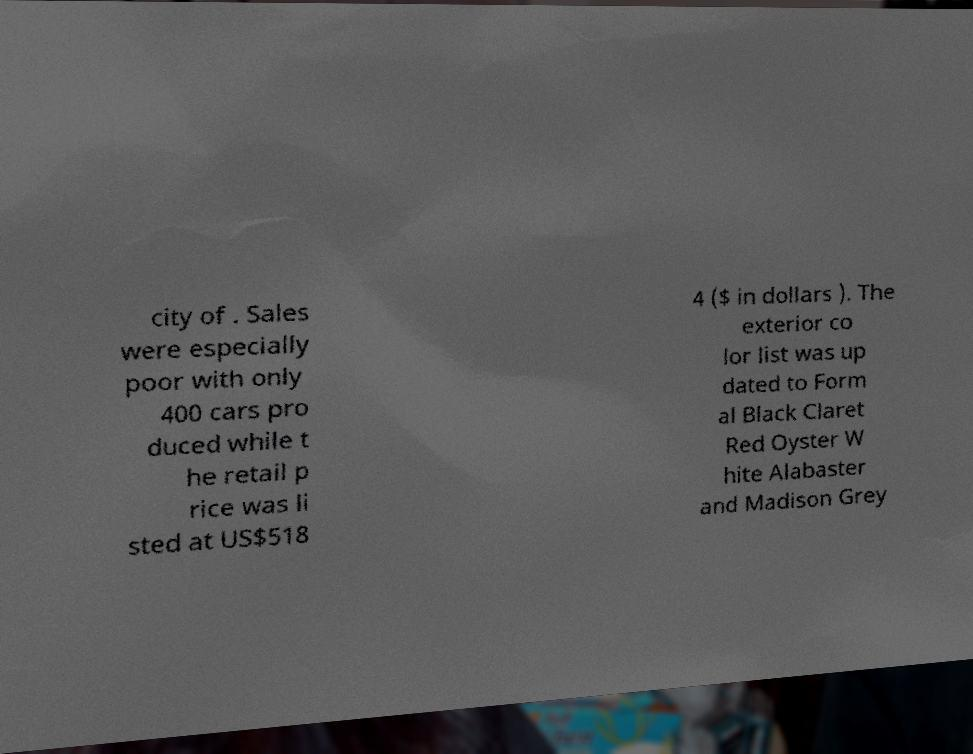Can you accurately transcribe the text from the provided image for me? city of . Sales were especially poor with only 400 cars pro duced while t he retail p rice was li sted at US$518 4 ($ in dollars ). The exterior co lor list was up dated to Form al Black Claret Red Oyster W hite Alabaster and Madison Grey 